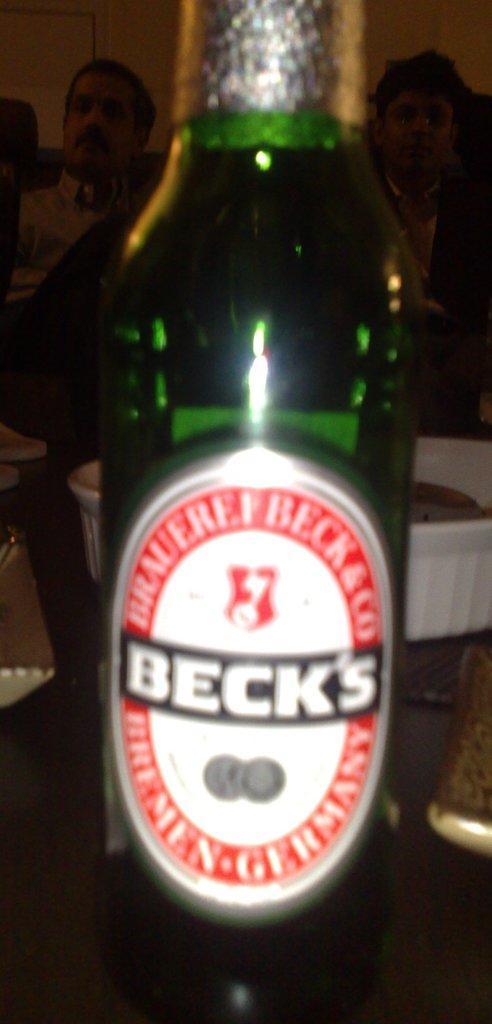Can you describe this image briefly? In this picture we can see a bottle on the table, in the background we can find couple of people. 